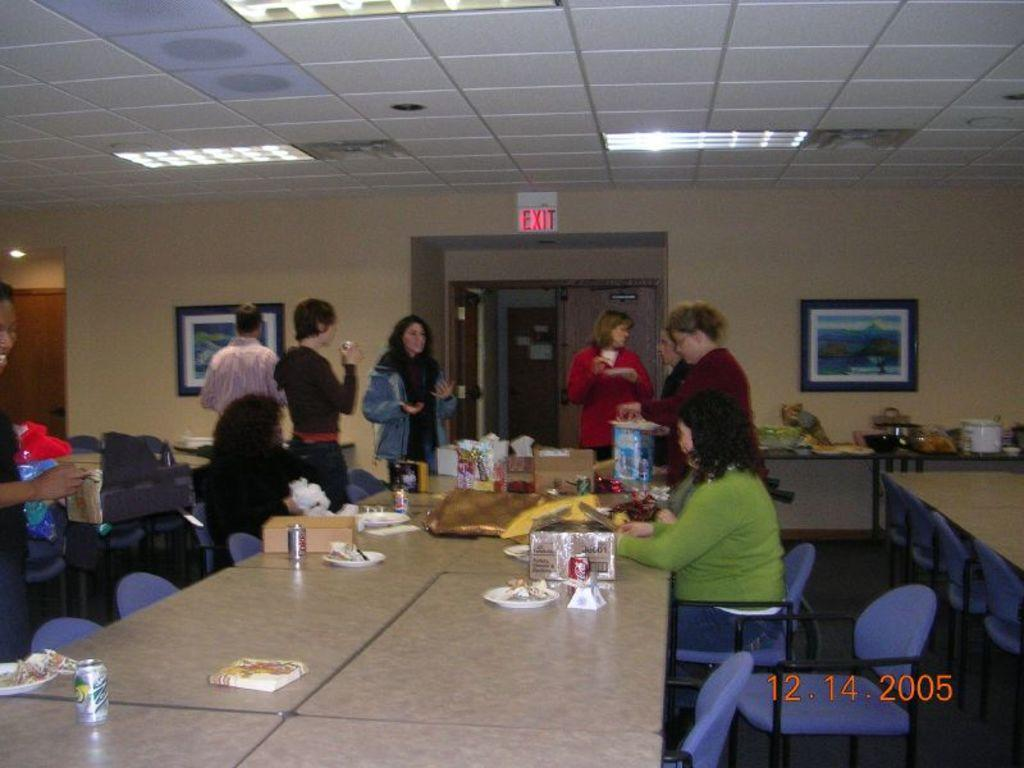How many women are sitting in the image? There are 2 women sitting on chairs in the image. What are the women sitting in front of? The women are in front of a table. What are the other people in the image doing? Other persons are standing in the image. What can be seen in the background of the image? There is a wall, a photo frame, and a sign board in the background of the image. Can you tell me how many cans the beggar is holding in the image? There is no beggar or cans present in the image. How does the balance of the sign board in the background of the image affect the stability of the photo frame? The balance of the sign board does not affect the stability of the photo frame in the image, as they are separate objects. 